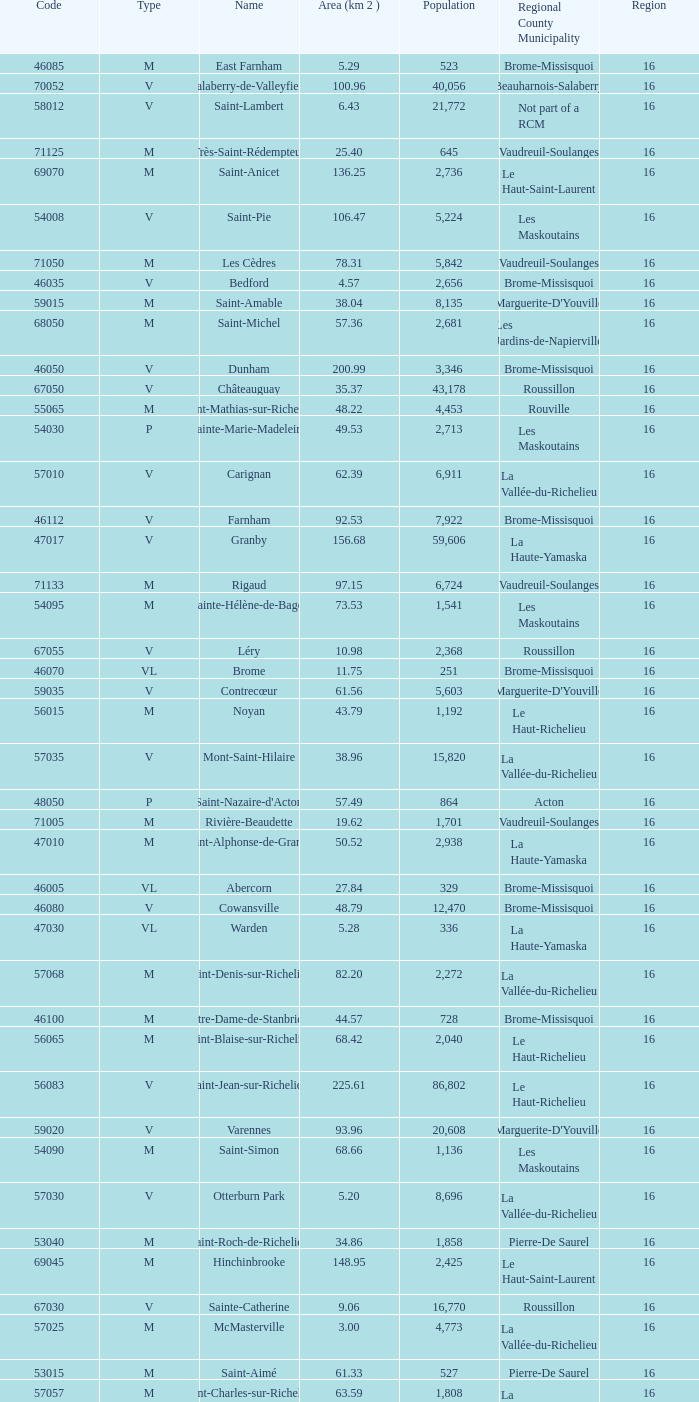Saint-Blaise-Sur-Richelieu is smaller than 68.42 km^2, what is the population of this type M municipality? None. 